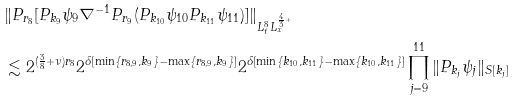Convert formula to latex. <formula><loc_0><loc_0><loc_500><loc_500>& \| P _ { r _ { 8 } } [ P _ { k _ { 9 } } \psi _ { 9 } \nabla ^ { - 1 } P _ { r _ { 9 } } ( P _ { k _ { 1 0 } } \psi _ { 1 0 } P _ { k _ { 1 1 } } \psi _ { 1 1 } ) ] \| _ { L _ { t } ^ { 8 } L _ { x } ^ { \frac { 4 } { 3 } + } } \\ & \lesssim 2 ^ { ( \frac { 3 } { 8 } + \nu ) r _ { 8 } } 2 ^ { \delta [ \min \{ r _ { 8 , 9 } , k _ { 9 } \} - \max \{ r _ { 8 , 9 } , k _ { 9 } \} ] } 2 ^ { \delta [ \min \{ k _ { 1 0 } , k _ { 1 1 } \} - \max \{ k _ { 1 0 } , k _ { 1 1 } \} ] } \prod _ { j = 9 } ^ { 1 1 } \| P _ { k _ { j } } \psi _ { j } \| _ { S [ k _ { j } ] }</formula> 